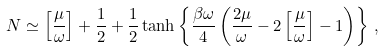Convert formula to latex. <formula><loc_0><loc_0><loc_500><loc_500>N \simeq \left [ \frac { \mu } { \omega } \right ] + \frac { 1 } { 2 } + \frac { 1 } { 2 } \tanh \left \{ \frac { \beta \omega } { 4 } \left ( \frac { 2 \mu } { \omega } - 2 \left [ \frac { \mu } { \omega } \right ] - 1 \right ) \right \} \, ,</formula> 